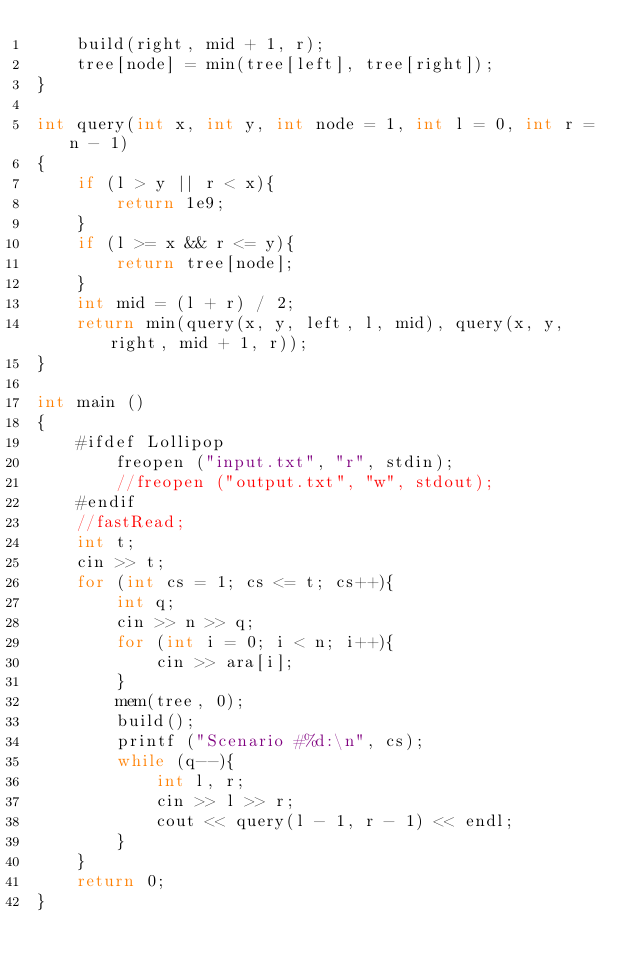<code> <loc_0><loc_0><loc_500><loc_500><_C++_>    build(right, mid + 1, r);
    tree[node] = min(tree[left], tree[right]);
}

int query(int x, int y, int node = 1, int l = 0, int r = n - 1)
{
    if (l > y || r < x){
        return 1e9;
    }
    if (l >= x && r <= y){
        return tree[node];
    }
    int mid = (l + r) / 2;
    return min(query(x, y, left, l, mid), query(x, y, right, mid + 1, r));
}

int main ()
{
    #ifdef Lollipop
        freopen ("input.txt", "r", stdin);
        //freopen ("output.txt", "w", stdout);
    #endif
    //fastRead;
    int t;
    cin >> t;
    for (int cs = 1; cs <= t; cs++){
        int q;
        cin >> n >> q;
        for (int i = 0; i < n; i++){
            cin >> ara[i];
        }
        mem(tree, 0);
        build();
        printf ("Scenario #%d:\n", cs);
        while (q--){
            int l, r;
            cin >> l >> r;
            cout << query(l - 1, r - 1) << endl;
        }
    }
    return 0;
}

</code> 